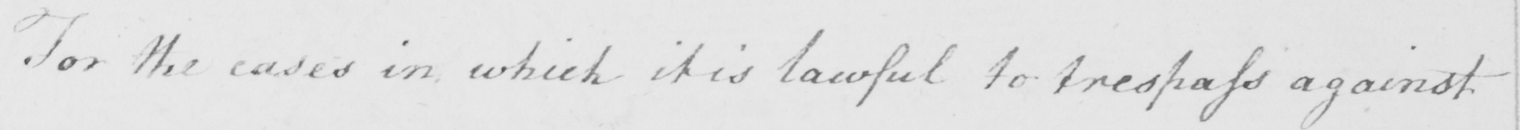Transcribe the text shown in this historical manuscript line. For the cases in which it is lawful to trespass against 